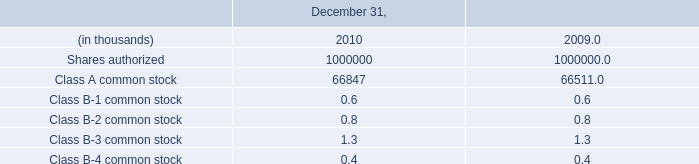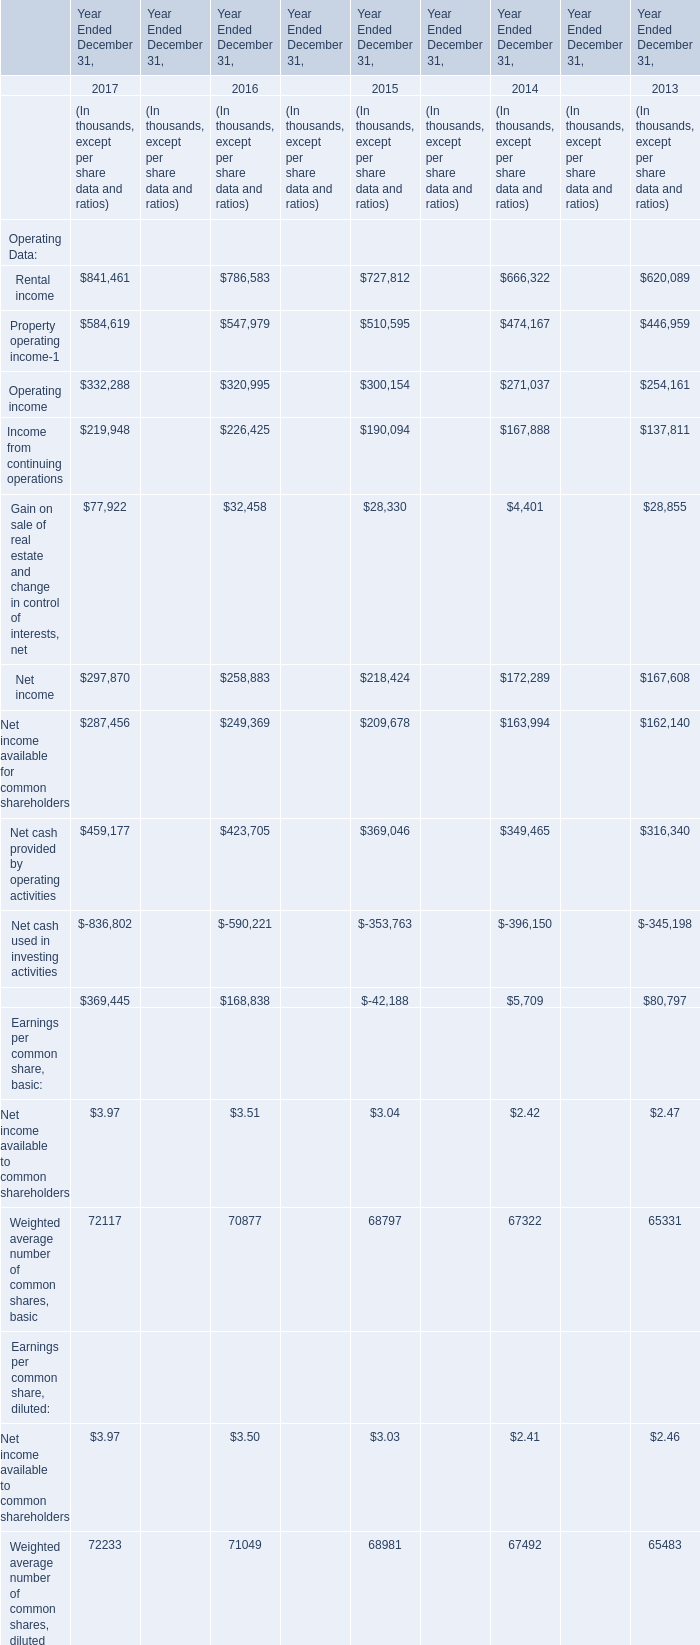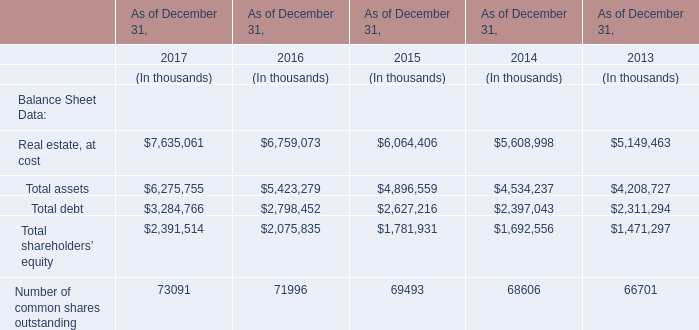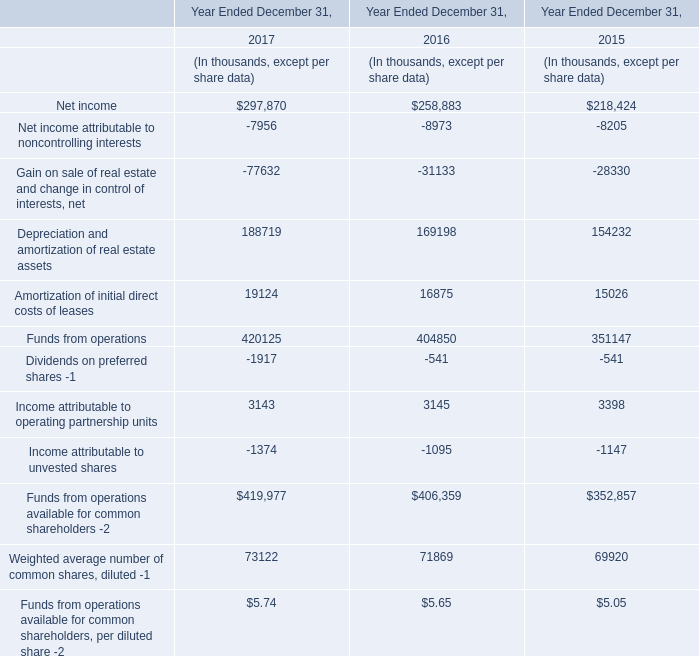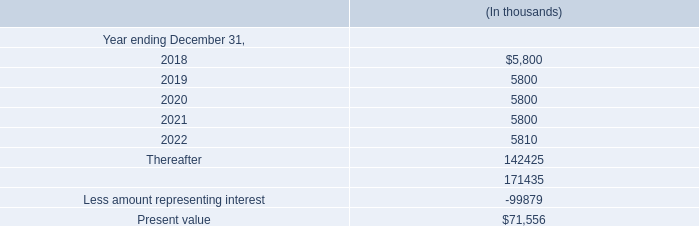What will Rental income be like in 2018 if it develops with the same increasing rate as current? (in thousand) 
Computations: (841461 * (1 + ((841461 - 786583) / 786583)))
Answer: 900167.70579. 